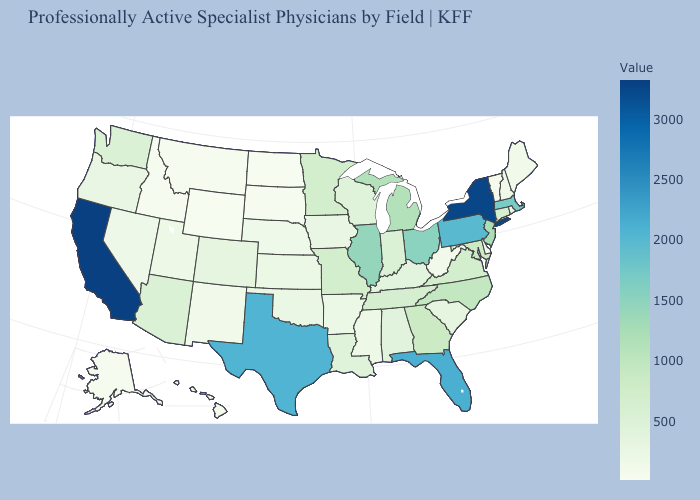Among the states that border Connecticut , which have the highest value?
Write a very short answer. New York. Does Texas have the lowest value in the South?
Keep it brief. No. Which states have the lowest value in the Northeast?
Short answer required. Vermont. Does Kansas have a higher value than Minnesota?
Give a very brief answer. No. Is the legend a continuous bar?
Answer briefly. Yes. 